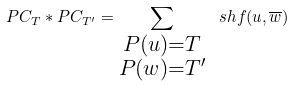Convert formula to latex. <formula><loc_0><loc_0><loc_500><loc_500>P C _ { T } \ast P C _ { T ^ { \prime } } = \sum _ { \substack { P ( u ) = T \\ P ( w ) = T ^ { \prime } } } \ s h f ( u , \overline { w } )</formula> 